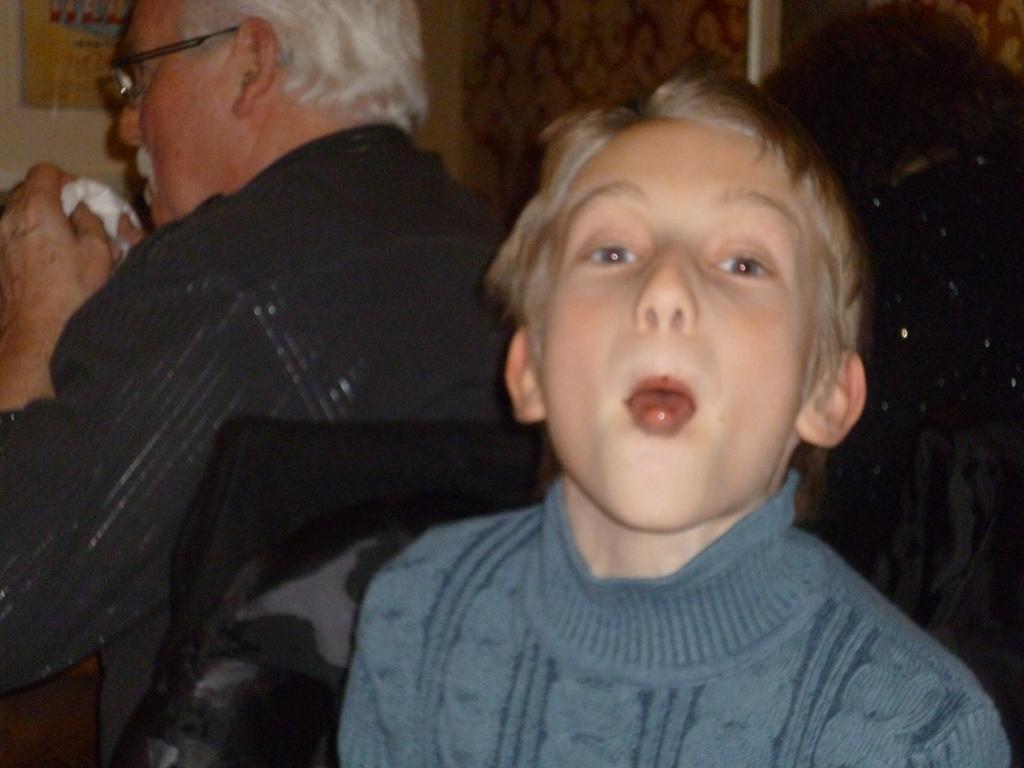Could you give a brief overview of what you see in this image? This image is taken indoors. In the background there is a wall and there is an old man sitting on the chair and holding a tissue paper in his hands. There is a board with a text on it. In the middle of the image there is a kid with a weird expression on his face. 